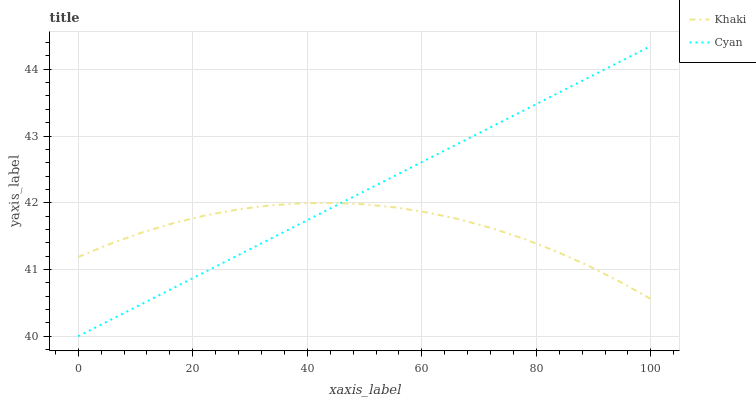Does Khaki have the minimum area under the curve?
Answer yes or no. Yes. Does Cyan have the maximum area under the curve?
Answer yes or no. Yes. Does Khaki have the maximum area under the curve?
Answer yes or no. No. Is Cyan the smoothest?
Answer yes or no. Yes. Is Khaki the roughest?
Answer yes or no. Yes. Is Khaki the smoothest?
Answer yes or no. No. Does Cyan have the lowest value?
Answer yes or no. Yes. Does Khaki have the lowest value?
Answer yes or no. No. Does Cyan have the highest value?
Answer yes or no. Yes. Does Khaki have the highest value?
Answer yes or no. No. Does Khaki intersect Cyan?
Answer yes or no. Yes. Is Khaki less than Cyan?
Answer yes or no. No. Is Khaki greater than Cyan?
Answer yes or no. No. 